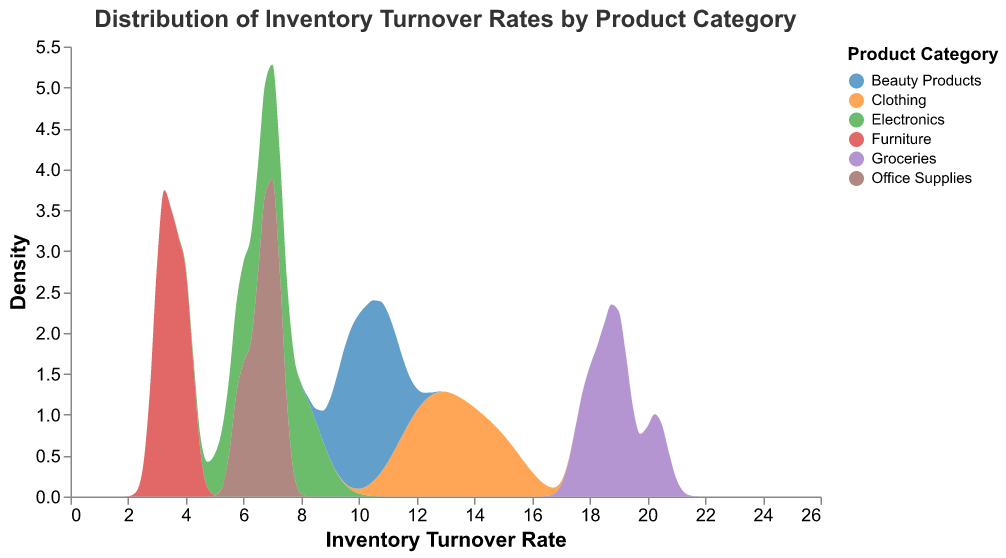What is the title of the figure? The title is displayed at the top of the figure, typically in larger font.
Answer: Distribution of Inventory Turnover Rates by Product Category What does the x-axis represent? The x-axis shows the range of values for the inventory turnover rates, which are the focus of the distribution analysis.
Answer: Inventory Turnover Rate Which product category has the highest inventory turnover rate? By looking at the distribution curves, the peak of the groceries category extends the furthest to the right on the x-axis.
Answer: Groceries How many product categories are represented in the figure? The legend shows different colors for each product category included in the figure.
Answer: 6 Which product categories have the lowest average inventory turnover rates? By examining the peaks and locations of the distributions on the x-axis, electronics and furniture appear lower on the turnover rate scale.
Answer: Electronics and Furniture In which range do most of the electronics inventory turnover rates fall? By observing the density curve for electronics, most values are concentrated between around 5 and 8 on the x-axis.
Answer: 5 to 8 Which product category has the widest range of inventory turnover rates? The spread of the categories can be seen by the length of their distribution on the x-axis, and clothing has values ranging from about 11.5 to 15.1.
Answer: Clothing Between furniture and office supplies, which has higher inventory turnover rates on average? By comparing the density peaks of the two distributions, office supplies have a higher average turnover rate than furniture.
Answer: Office Supplies How does the distribution of beauty products compare to clothing? The distribution for beauty products is also relatively high but not as high as clothing, and the range is narrower than clothing.
Answer: Narrower and lower than clothing Is there any overlap in the turnover rate ranges between beauty products and groceries? By observing the distribution curves, beauty products range from about 9.5 to 11.2, while groceries’ range is higher, so there is no overlap.
Answer: No 